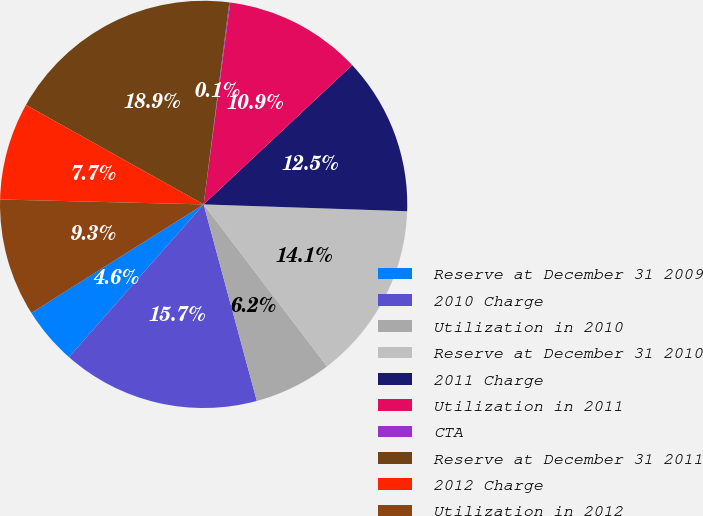Convert chart to OTSL. <chart><loc_0><loc_0><loc_500><loc_500><pie_chart><fcel>Reserve at December 31 2009<fcel>2010 Charge<fcel>Utilization in 2010<fcel>Reserve at December 31 2010<fcel>2011 Charge<fcel>Utilization in 2011<fcel>CTA<fcel>Reserve at December 31 2011<fcel>2012 Charge<fcel>Utilization in 2012<nl><fcel>4.55%<fcel>15.71%<fcel>6.15%<fcel>14.11%<fcel>12.52%<fcel>10.93%<fcel>0.07%<fcel>18.89%<fcel>7.74%<fcel>9.33%<nl></chart> 